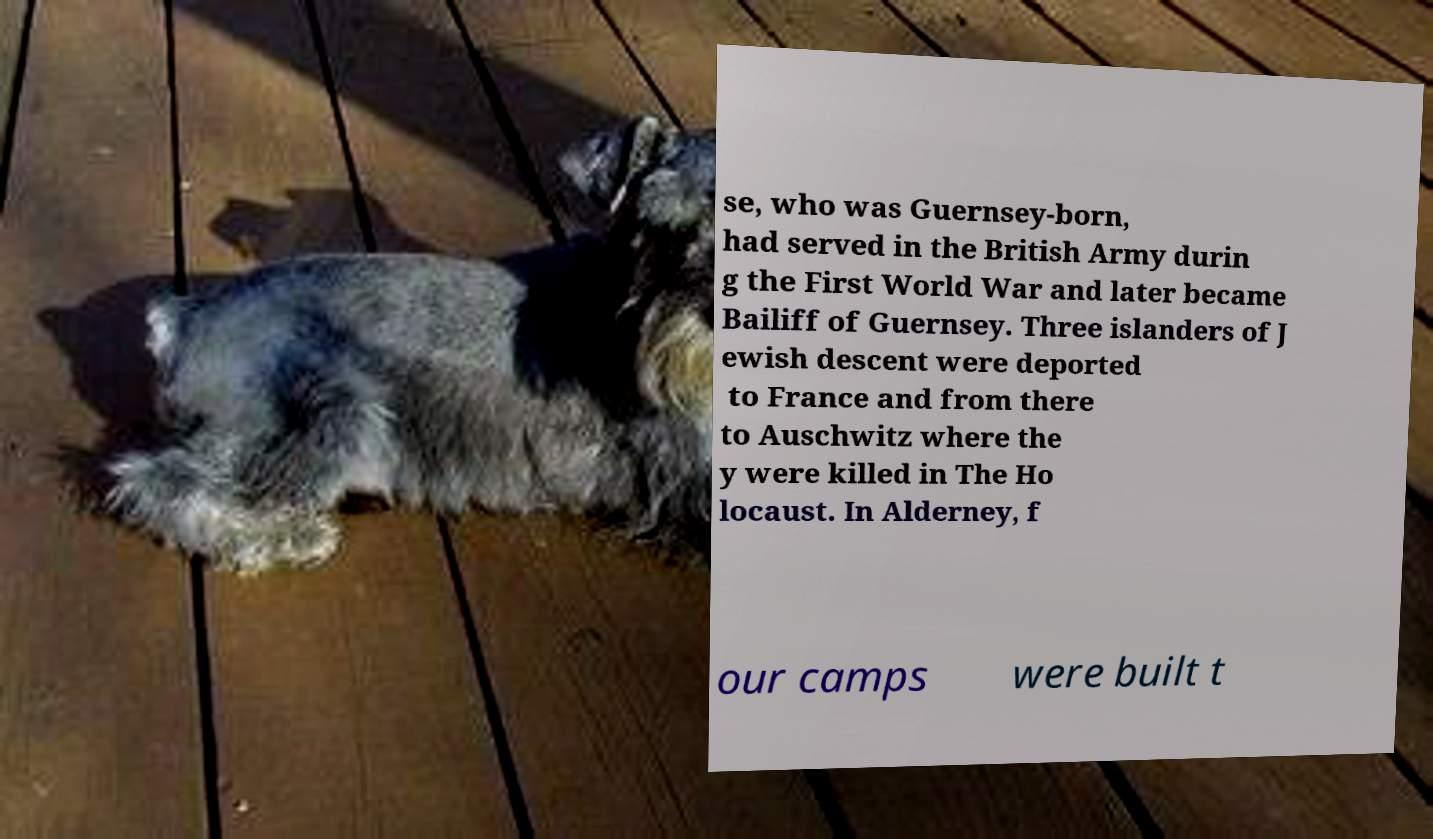There's text embedded in this image that I need extracted. Can you transcribe it verbatim? se, who was Guernsey-born, had served in the British Army durin g the First World War and later became Bailiff of Guernsey. Three islanders of J ewish descent were deported to France and from there to Auschwitz where the y were killed in The Ho locaust. In Alderney, f our camps were built t 